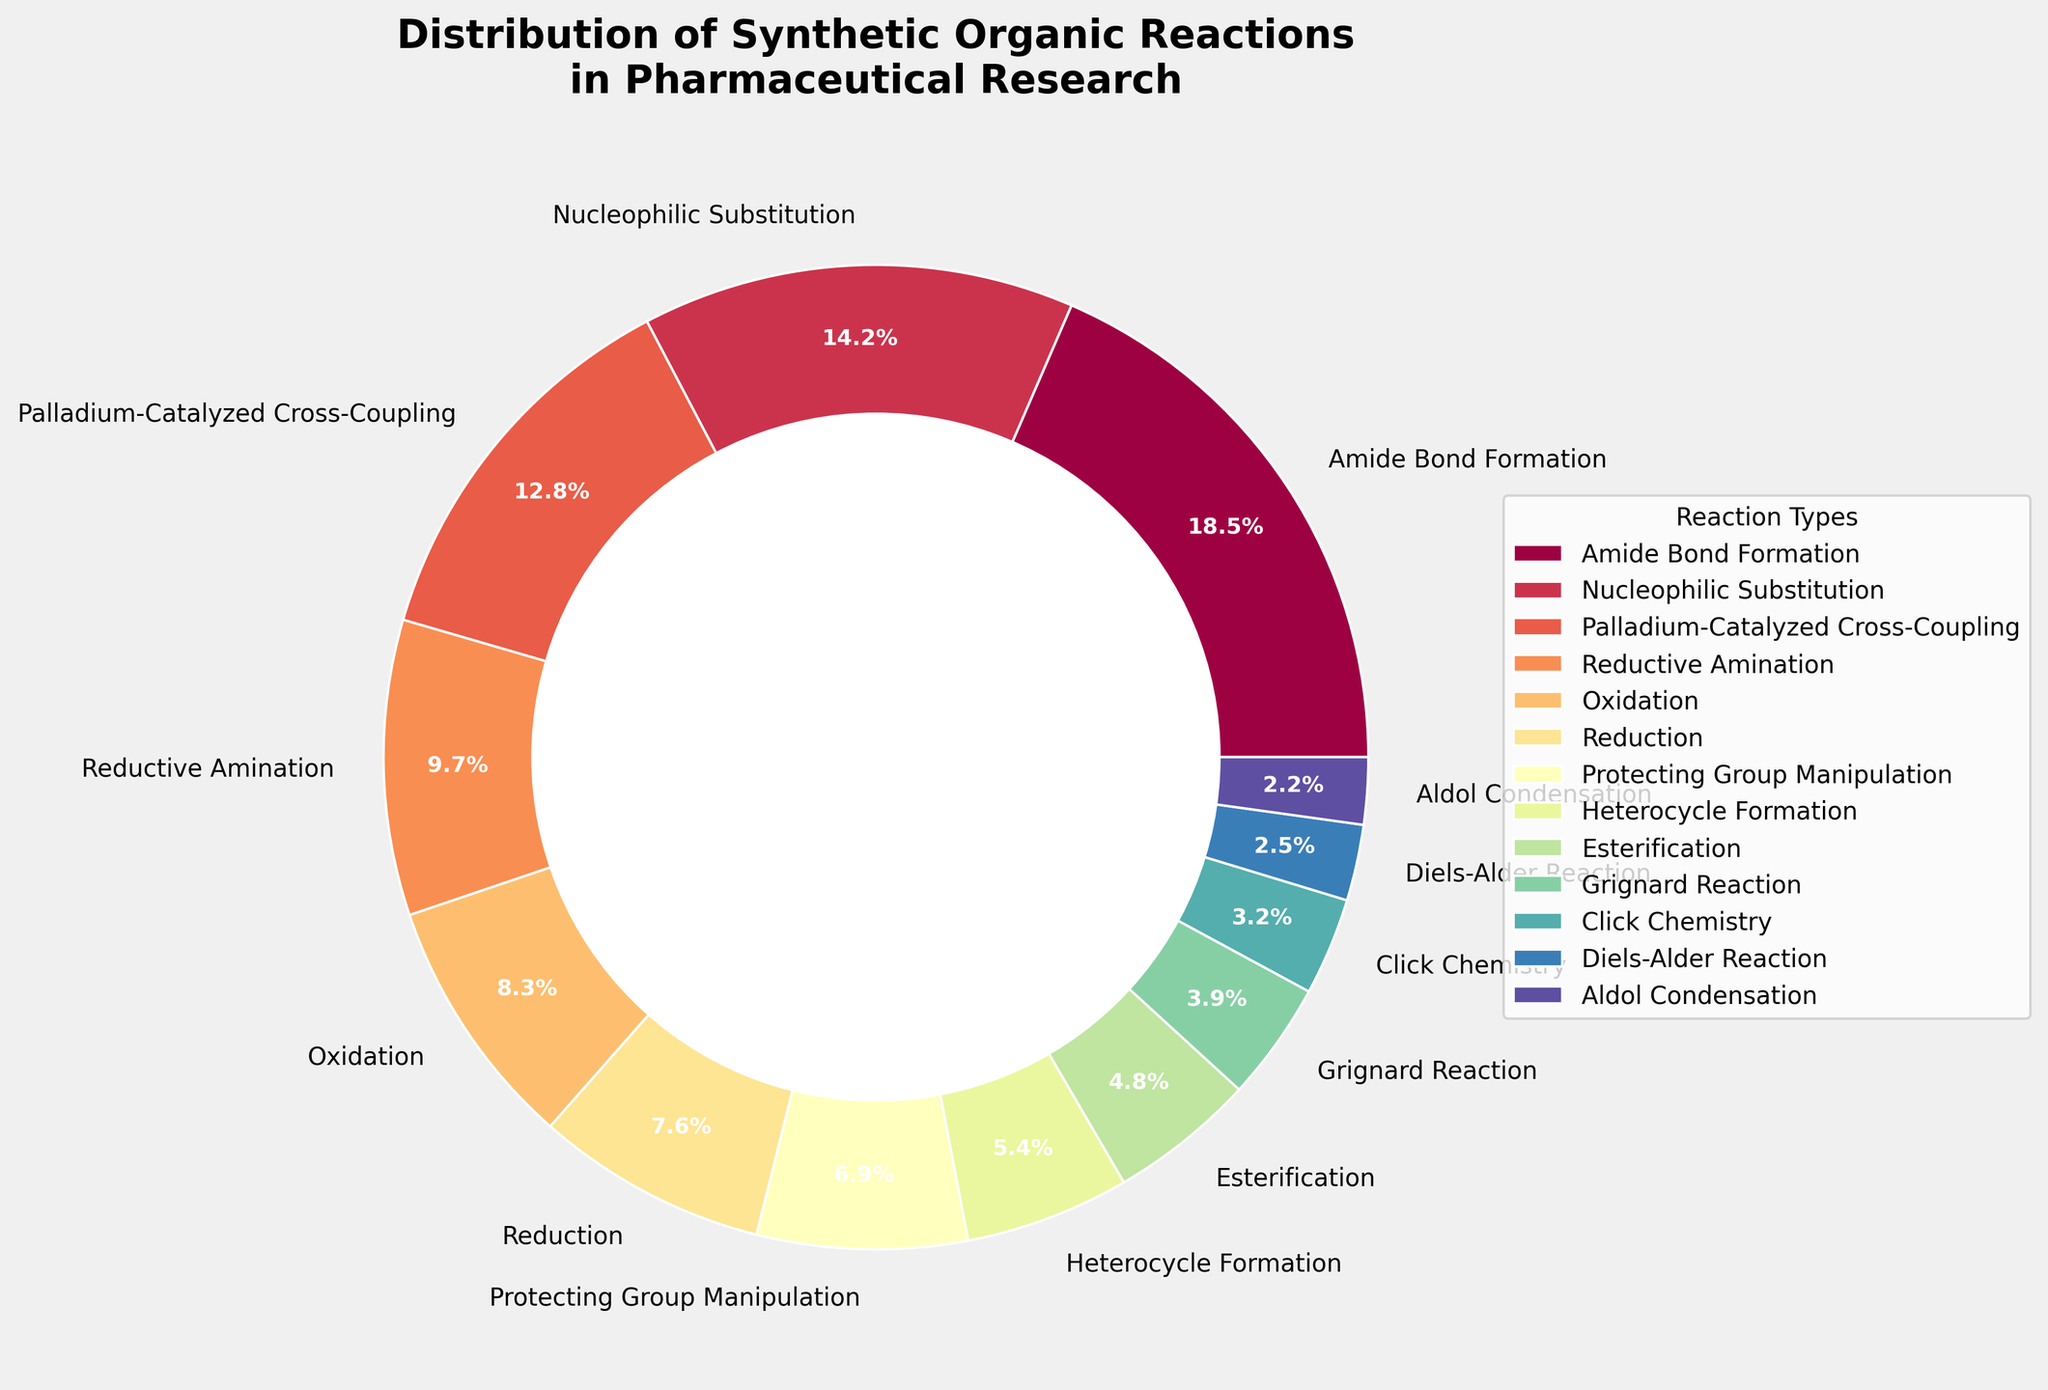What's the most common type of synthetic organic reaction used in pharmaceutical research? By looking at the pie chart, the size of each slice indicates the proportion of each reaction type. The largest slice represents the most common reaction type.
Answer: Amide Bond Formation What's the least common reaction type, and what percentage does it represent? The smallest slice in the pie chart indicates the least common reaction type. The label on this slice shows its percentage.
Answer: Aldol Condensation, 2.2% Which reaction types make up more than 10% of the total, and what are their percentages? Look for slices in the pie chart with labels showing percentages greater than 10%. Sum up and list the reaction types and their respective percentages.
Answer: Amide Bond Formation (18.5%), Nucleophilic Substitution (14.2%), Palladium-Catalyzed Cross-Coupling (12.8%) How much more frequent is Amide Bond Formation compared to Reduction? Find the percentages of Amide Bond Formation and Reduction, then subtract the percentage of Reduction from that of Amide Bond Formation.
Answer: 18.5% - 7.6% = 10.9% If we combine the percentages of Oxidation, Reduction, and Protecting Group Manipulation, what is the sum? Locate the slices for Oxidation, Reduction, and Protecting Group Manipulation. Add their percentages together.
Answer: 8.3% + 7.6% + 6.9% = 22.8% What is the visual color range used to distinguish between different reaction types? The pie chart uses a range of colors to differentiate between slices. Examine the colors that range from dark to light shades.
Answer: Spectral colormap with a gradient from dark red to light yellow Which two reaction types have an identical color, and how can we distinguish them? Check if any slices share identical colors (visual observation). Mention the feature used to distinguish them (usually the labels).
Answer: No two slices have identical colors; distinguished by unique labels Arrange the reaction types in descending order based on their percentages. Rank the reaction types by their slice sizes and percentages from largest to smallest.
Answer: Amide Bond Formation, Nucleophilic Substitution, Palladium-Catalyzed Cross-Coupling, Reductive Amination, Oxidation, Reduction, Protecting Group Manipulation, Heterocycle Formation, Esterification, Grignard Reaction, Click Chemistry, Diels-Alder Reaction, Aldol Condensation Which reaction types contribute less than 5% to the total, and what percentages do they represent? Look for slices with percentages below 5% and list their reaction types along with their percentages.
Answer: Esterification (4.8%), Grignard Reaction (3.9%), Click Chemistry (3.2%), Diels-Alder Reaction (2.5%), Aldol Condensation (2.2%) What is the percentage difference between Nucleophilic Substitution and Click Chemistry? Find and subtract the percentage of Click Chemistry from that of Nucleophilic Substitution.
Answer: 14.2% - 3.2% = 11% How is the data distribution visually emphasized in the pie chart? Identify the visual elements such as the size of slices, color variations, and the addition of the central circle in the pie chart.
Answer: Slice size, varying colors, central white circle 